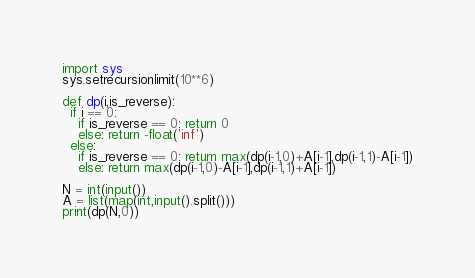<code> <loc_0><loc_0><loc_500><loc_500><_Python_>import sys
sys.setrecursionlimit(10**6)

def dp(i,is_reverse):
  if i == 0:
    if is_reverse == 0: return 0
    else: return -float('inf')
  else:
    if is_reverse == 0: return max(dp(i-1,0)+A[i-1],dp(i-1,1)-A[i-1])
    else: return max(dp(i-1,0)-A[i-1],dp(i-1,1)+A[i-1])

N = int(input())
A = list(map(int,input().split()))
print(dp(N,0))</code> 